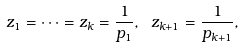Convert formula to latex. <formula><loc_0><loc_0><loc_500><loc_500>z _ { 1 } = \dots = z _ { k } = \frac { 1 } { p _ { 1 } } , \text { } z _ { k + 1 } = \frac { 1 } { p _ { k + 1 } } ,</formula> 